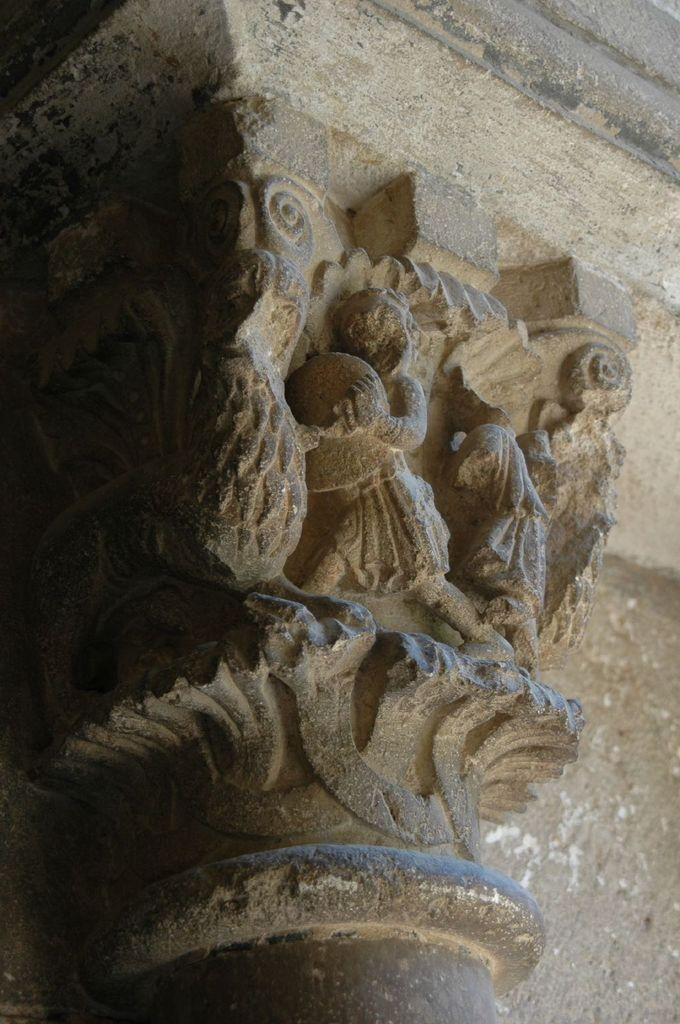What type of objects are featured in the image? There are white-colored sculptures in the image. What type of hospital is depicted in the image? There is no hospital depicted in the image; it features white-colored sculptures. What story is being told by the sculptures in the image? The image does not convey a story; it simply shows white-colored sculptures. 